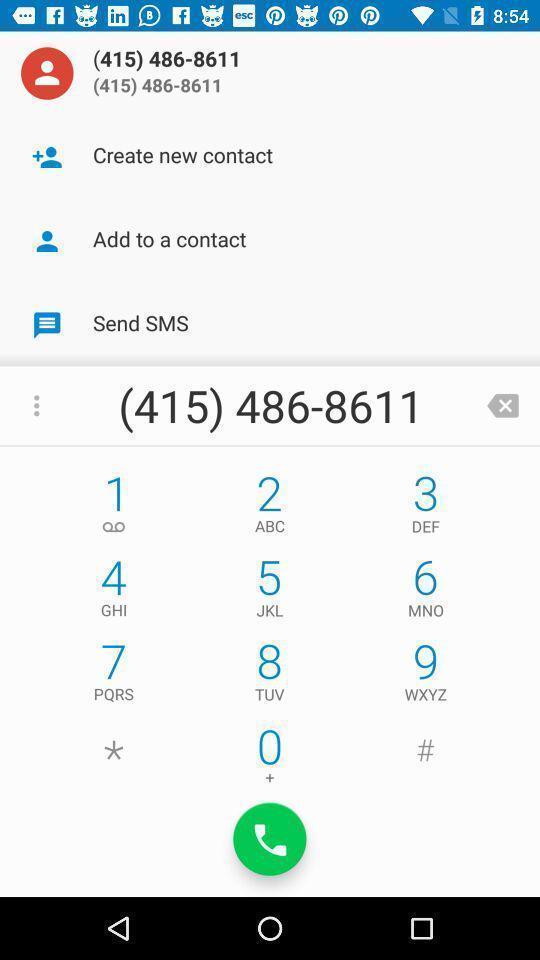Provide a description of this screenshot. Page showing a phones number dialing interface. 